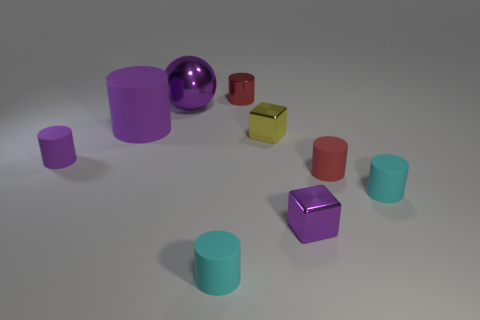Are there fewer big green matte blocks than tiny purple rubber cylinders? After carefully examining the image, it appears that there is indeed a smaller number of large green matte blocks compared to the tiny purple rubber cylinders. 